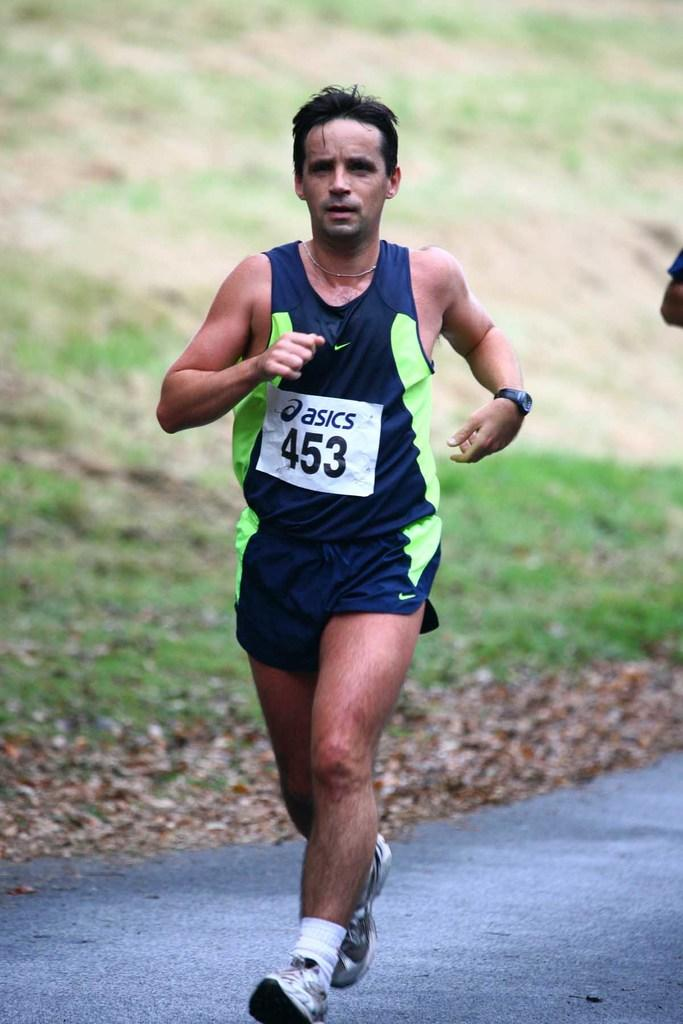Who is the main subject in the image? There is a man in the image. What is the man doing in the image? The man is running on the road. What can be seen in the background of the image? There is grass and dry leaves in the background of the image. What is the mass of the team in the image? There is no team present in the image, so it is not possible to determine the mass of a team. 